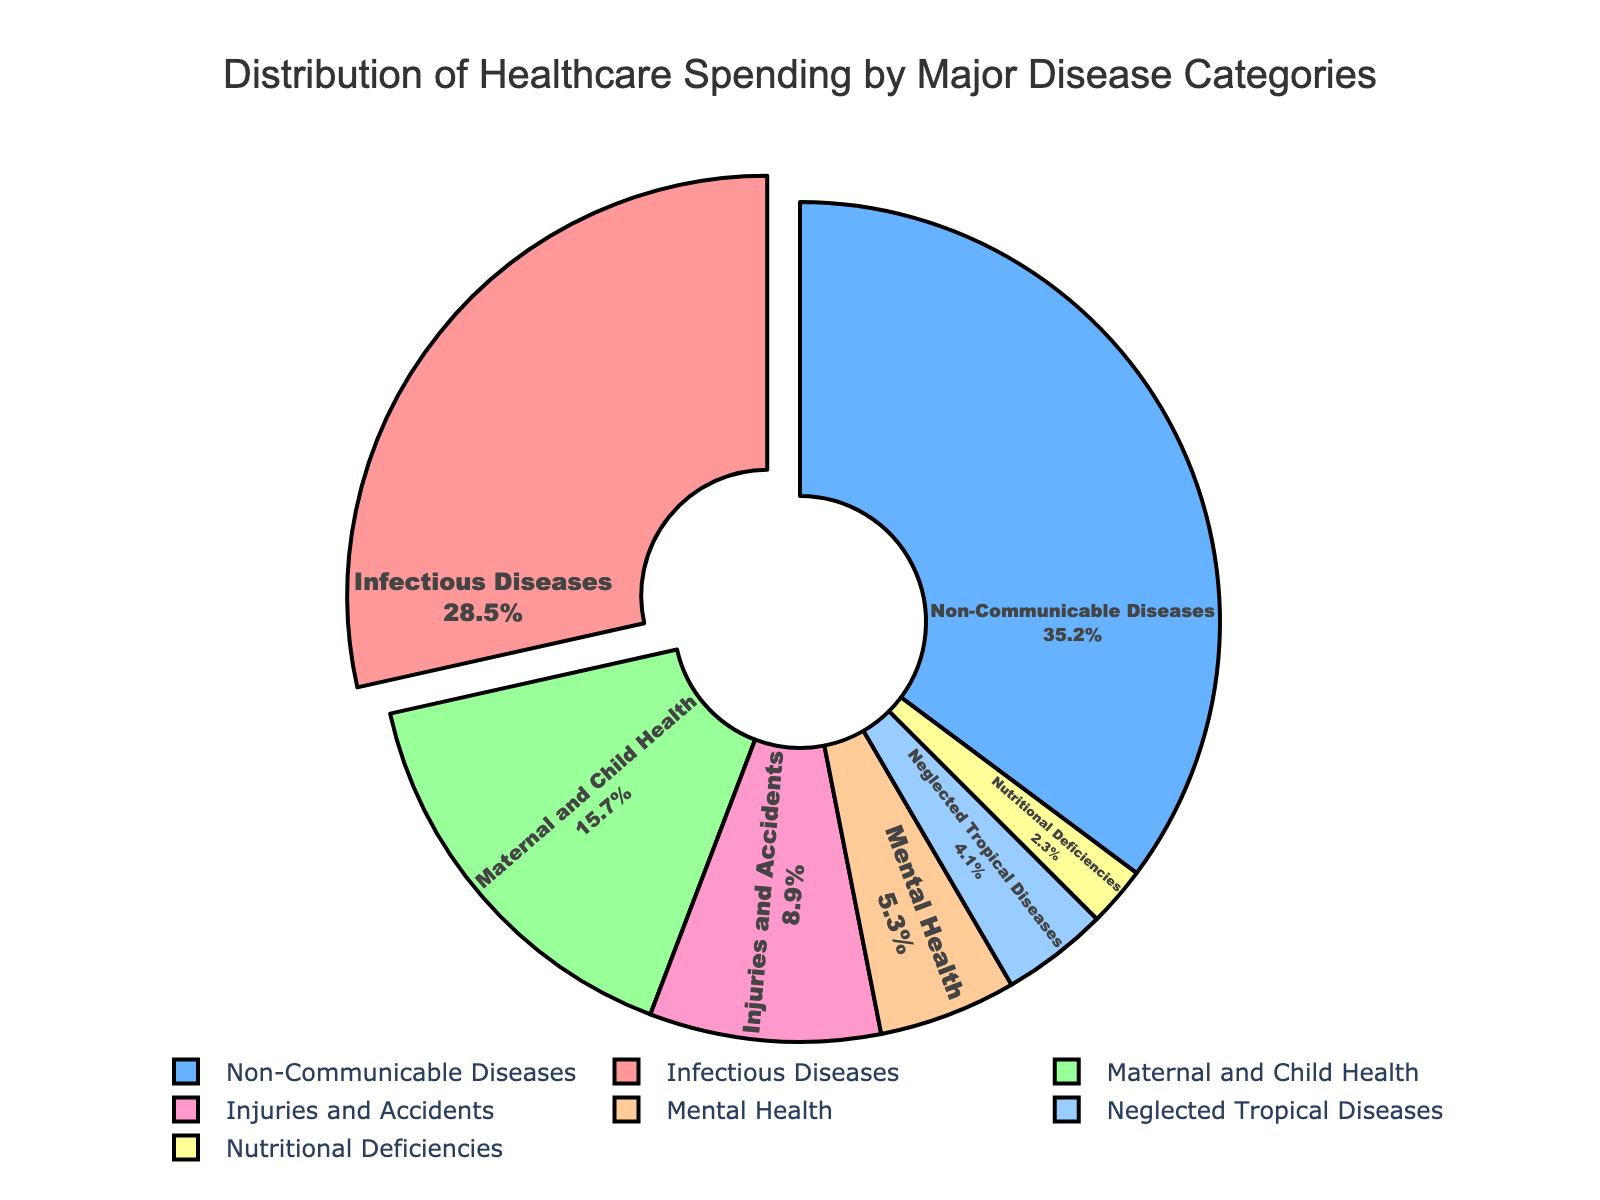Which disease category receives the highest percentage of healthcare spending? The slice labeled "Non-Communicable Diseases" is the largest portion of the pie chart, and by reading the figure, we can see it is 35.2%.
Answer: Non-Communicable Diseases What percentage of healthcare spending is directed towards Mental Health? Locate the slice labeled "Mental Health" in the chart, which indicates a percentage of 5.3%.
Answer: 5.3% How much more is spent on Infectious Diseases compared to Injuries and Accidents? Infectious Diseases account for 28.5% while Injuries and Accidents account for 8.9%. Subtracting these gives the difference: 28.5% - 8.9% = 19.6%.
Answer: 19.6% What is the total percentage of healthcare spending on Maternal and Child Health and Nutritional Deficiencies combined? The percentages for Maternal and Child Health (15.7%) and Nutritional Deficiencies (2.3%) add up: 15.7% + 2.3% = 18.0%.
Answer: 18.0% Which category receives the least amount of healthcare spending? By examining the figure, the smallest slice corresponds to "Nutritional Deficiencies" at 2.3%.
Answer: Nutritional Deficiencies Is spending on Infectious Diseases more, less, or equal to the combined spending on Mental Health and Neglected Tropical Diseases? Add the percentages for Mental Health (5.3%) and Neglected Tropical Diseases (4.1%): 5.3% + 4.1% = 9.4%. Since 28.5% (Infectious Diseases) is greater than 9.4%, spending on Infectious Diseases is more.
Answer: More Compare the spending on Non-Communicable Diseases and Maternal and Child Health. By how much percentage is one greater than the other? Non-Communicable Diseases is 35.2%. Maternal and Child Health is 15.7%. The difference is 35.2% - 15.7% = 19.5%.
Answer: 19.5% What percentage of healthcare spending goes to categories other than Non-Communicable Diseases? Non-Communicable Diseases take up 35.2%. So, the remaining is 100% - 35.2% = 64.8%.
Answer: 64.8% What is the average percentage of healthcare spending for Infectious Diseases, Injuries and Accidents, and Neglected Tropical Diseases? Add the three percentages: 28.5% (Infectious Diseases) + 8.9% (Injuries and Accidents) + 4.1% (Neglected Tropical Diseases) = 41.5%. Divide by 3: 41.5% / 3 ≈ 13.8%.
Answer: 13.8% 